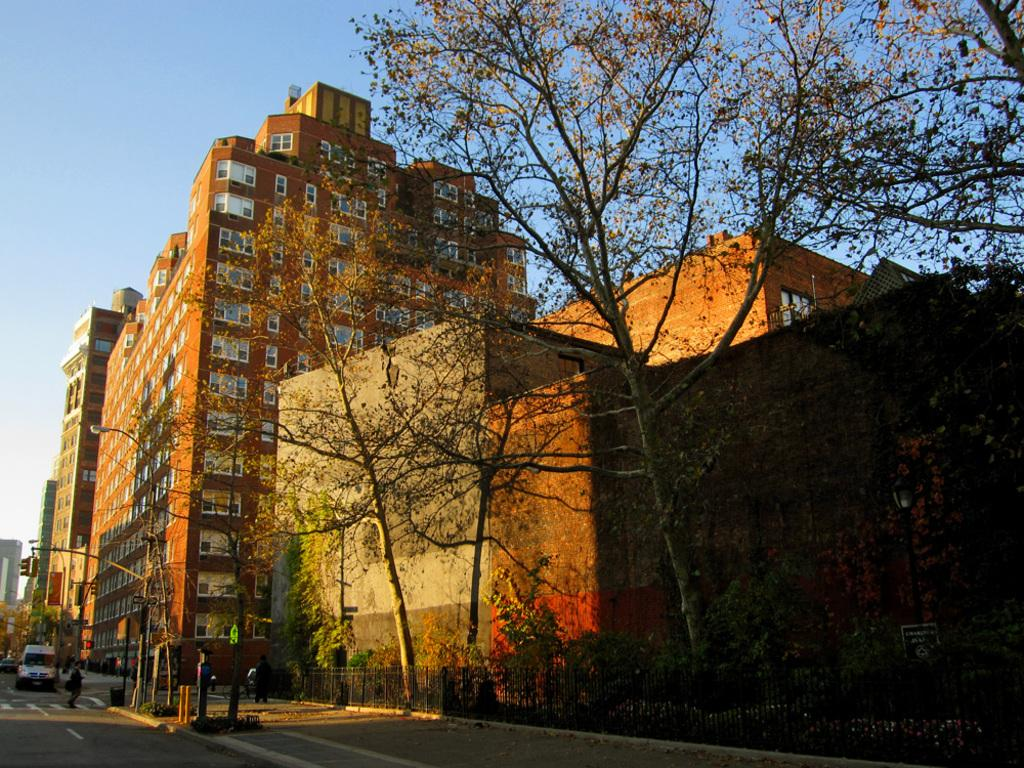What is the main subject of the image? The image shows a view of the roadside. What type of building can be seen on the right corner of the image? There is a brown big building on the right corner of the image. What color are the windows of the building? The building has white color windows. What type of vegetation is visible in the image? There are dry trees visible in the image. How many mice can be seen running along the edge of the building in the image? There are no mice visible in the image, and therefore no such activity can be observed. 